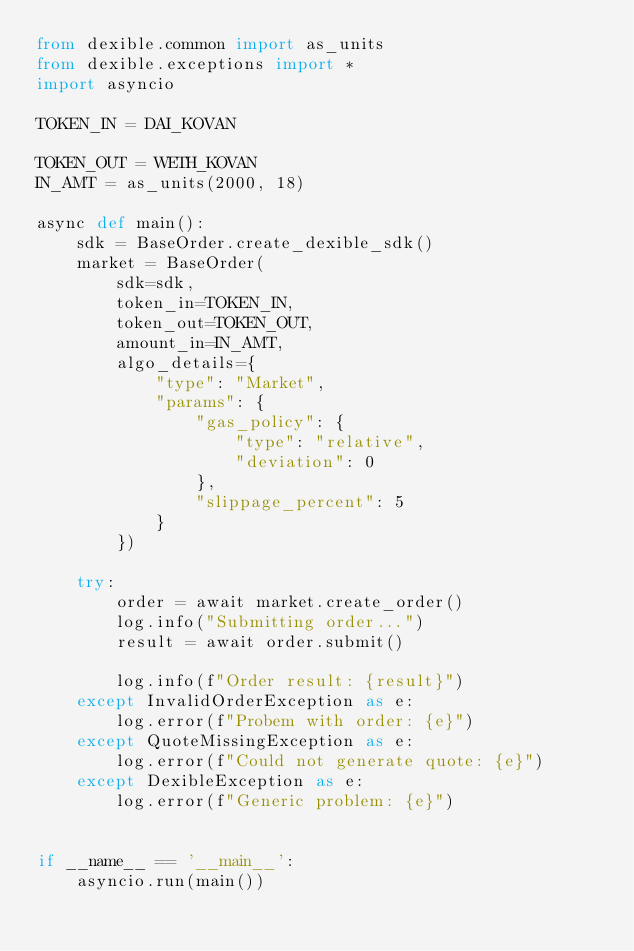Convert code to text. <code><loc_0><loc_0><loc_500><loc_500><_Python_>from dexible.common import as_units
from dexible.exceptions import *
import asyncio

TOKEN_IN = DAI_KOVAN

TOKEN_OUT = WETH_KOVAN
IN_AMT = as_units(2000, 18)

async def main():
    sdk = BaseOrder.create_dexible_sdk()
    market = BaseOrder(
        sdk=sdk,
        token_in=TOKEN_IN,
        token_out=TOKEN_OUT,
        amount_in=IN_AMT,
        algo_details={
            "type": "Market",
            "params": {
                "gas_policy": {
                    "type": "relative",
                    "deviation": 0
                },
                "slippage_percent": 5
            }
        })

    try:
        order = await market.create_order()
        log.info("Submitting order...")
        result = await order.submit()

        log.info(f"Order result: {result}")
    except InvalidOrderException as e:
        log.error(f"Probem with order: {e}")
    except QuoteMissingException as e:
        log.error(f"Could not generate quote: {e}")
    except DexibleException as e:
        log.error(f"Generic problem: {e}")


if __name__ == '__main__':
    asyncio.run(main())


</code> 